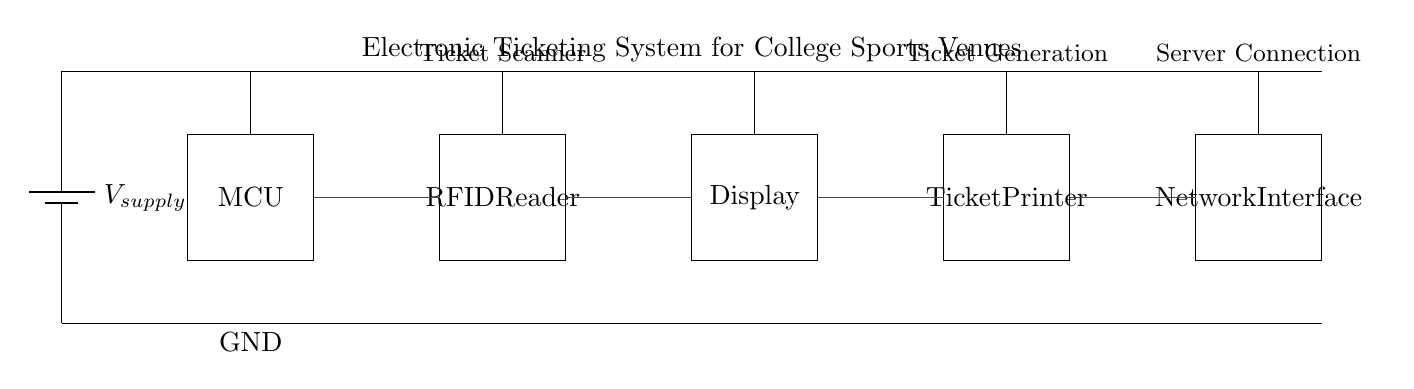What is the source voltage for this circuit? The source voltage is represented by \( V_{supply} \) in the circuit diagram, which indicates the power supply feeding the entire circuit.
Answer: V supply What components are included in the ticketing system? The circuit diagram displays five main components: a microcontroller, an RFID reader, a display, a ticket printer, and a network interface.
Answer: 5 How does data flow between the components? Data flows through the red lines connecting each component sequentially: from the microcontroller to the RFID reader, then to the display, followed by the ticket printer, and finally to the network interface.
Answer: Sequentially What is the function of the RFID reader in this system? The RFID reader is designed to scan for tickets, identifying and verifying them before any processing takes place for entry at sports venues.
Answer: Scanning tickets Explain the relationship between the ticket printer and the network interface. The ticket printer generates physical tickets based on the processed data, while the network interface connects the system to the server for remote ticket validation and record-keeping. The printer is downstream from the network interface, indicating that data is processed before ticket generation.
Answer: Ticket generation after processing What is the purpose of the microcontroller in this circuit? The microcontroller serves as the central processing unit, managing operations and controlling the interaction between the RFID reader, display, ticket printer, and network interface based on the data received from the RFID reader.
Answer: Central processing unit 